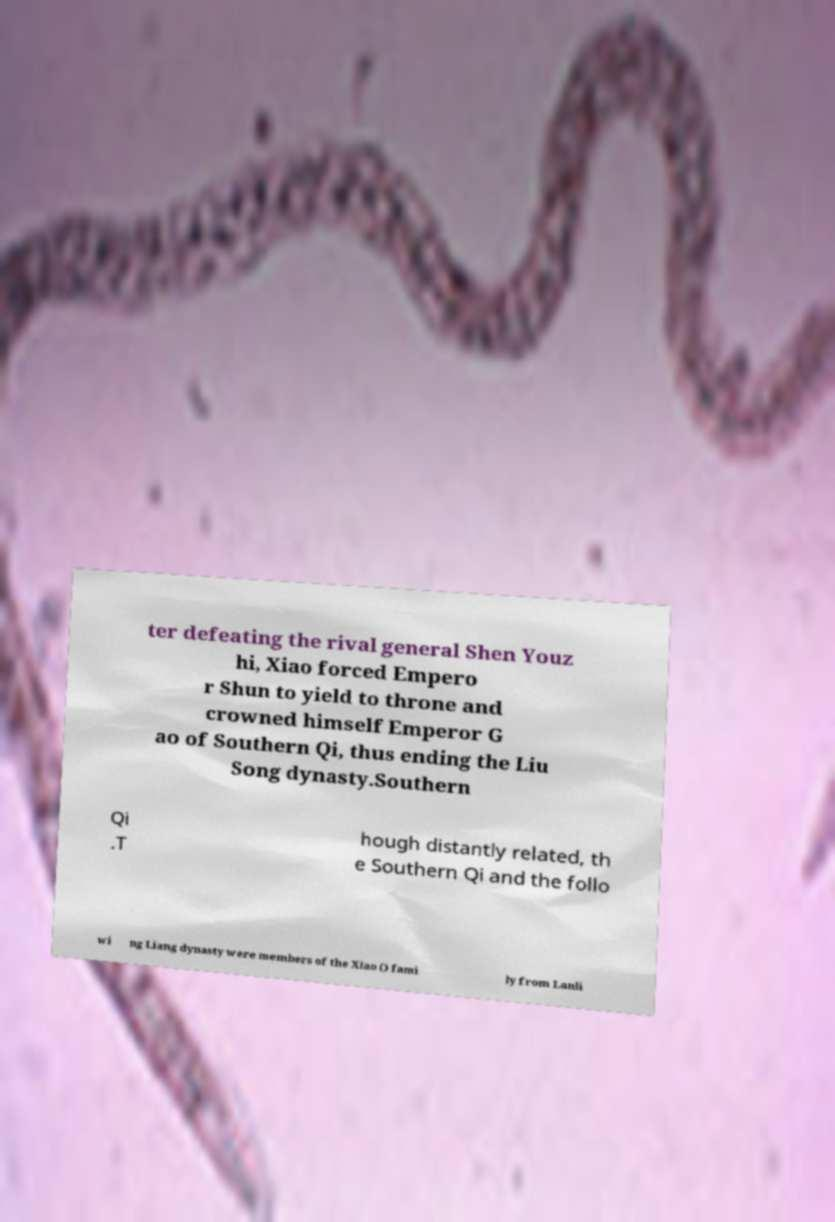Can you accurately transcribe the text from the provided image for me? ter defeating the rival general Shen Youz hi, Xiao forced Empero r Shun to yield to throne and crowned himself Emperor G ao of Southern Qi, thus ending the Liu Song dynasty.Southern Qi .T hough distantly related, th e Southern Qi and the follo wi ng Liang dynasty were members of the Xiao () fami ly from Lanli 